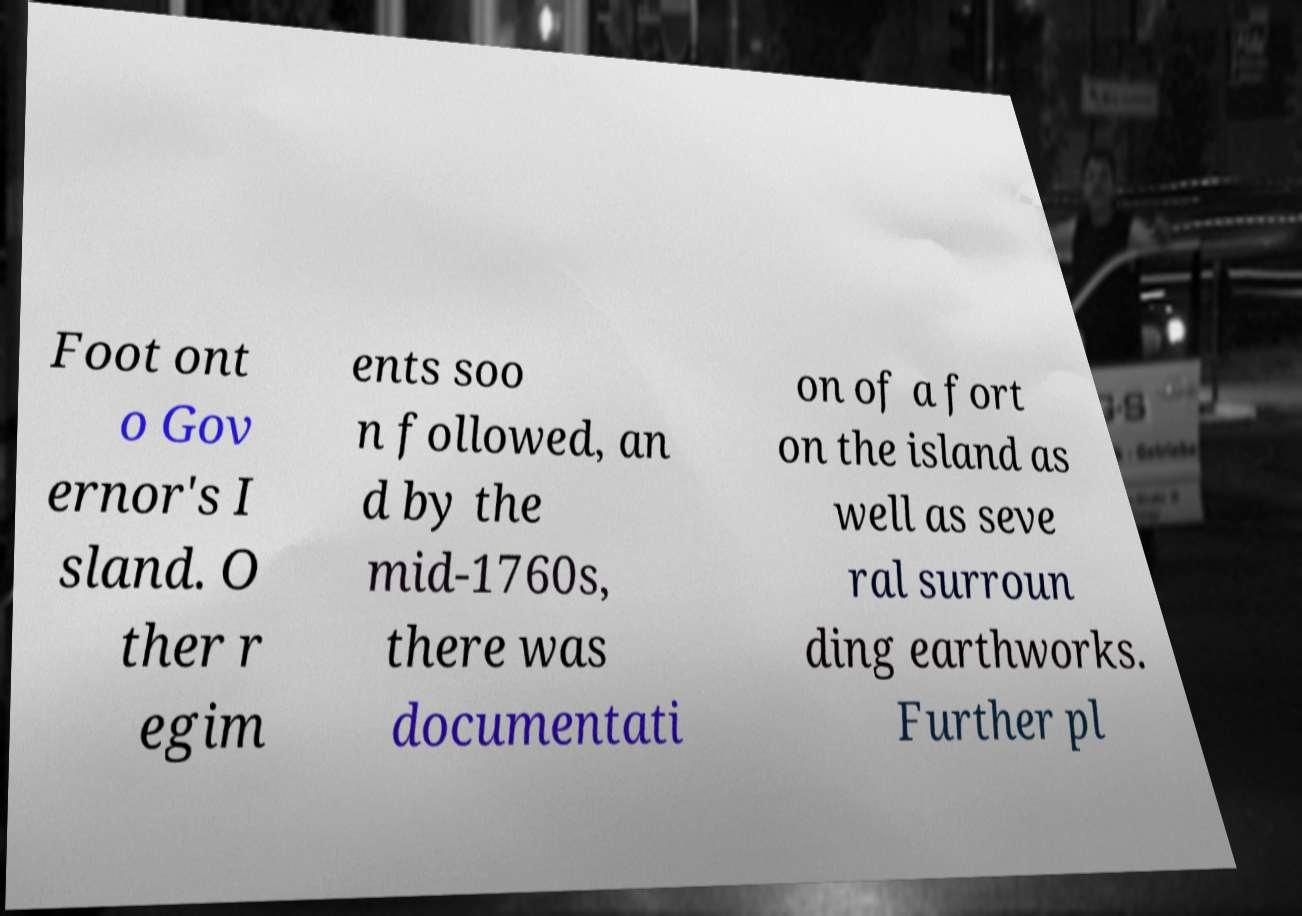What messages or text are displayed in this image? I need them in a readable, typed format. Foot ont o Gov ernor's I sland. O ther r egim ents soo n followed, an d by the mid-1760s, there was documentati on of a fort on the island as well as seve ral surroun ding earthworks. Further pl 